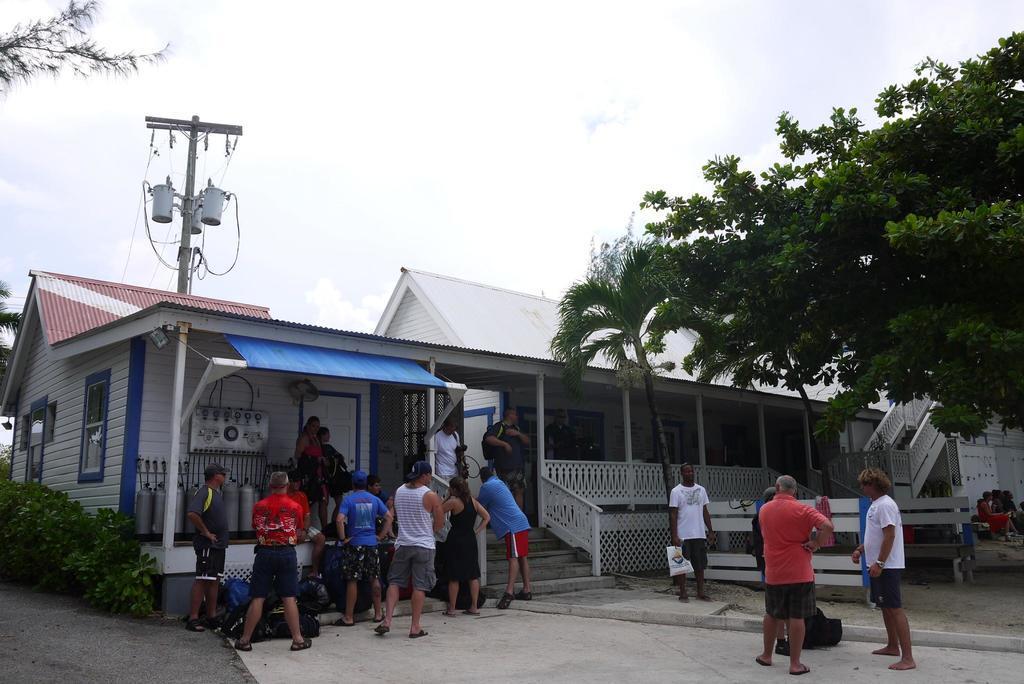In one or two sentences, can you explain what this image depicts? There are people, plants, trees and a house structure in the foreground area of the image, it seems like vending machines and a pole on the left side, there is the sky in the background. 